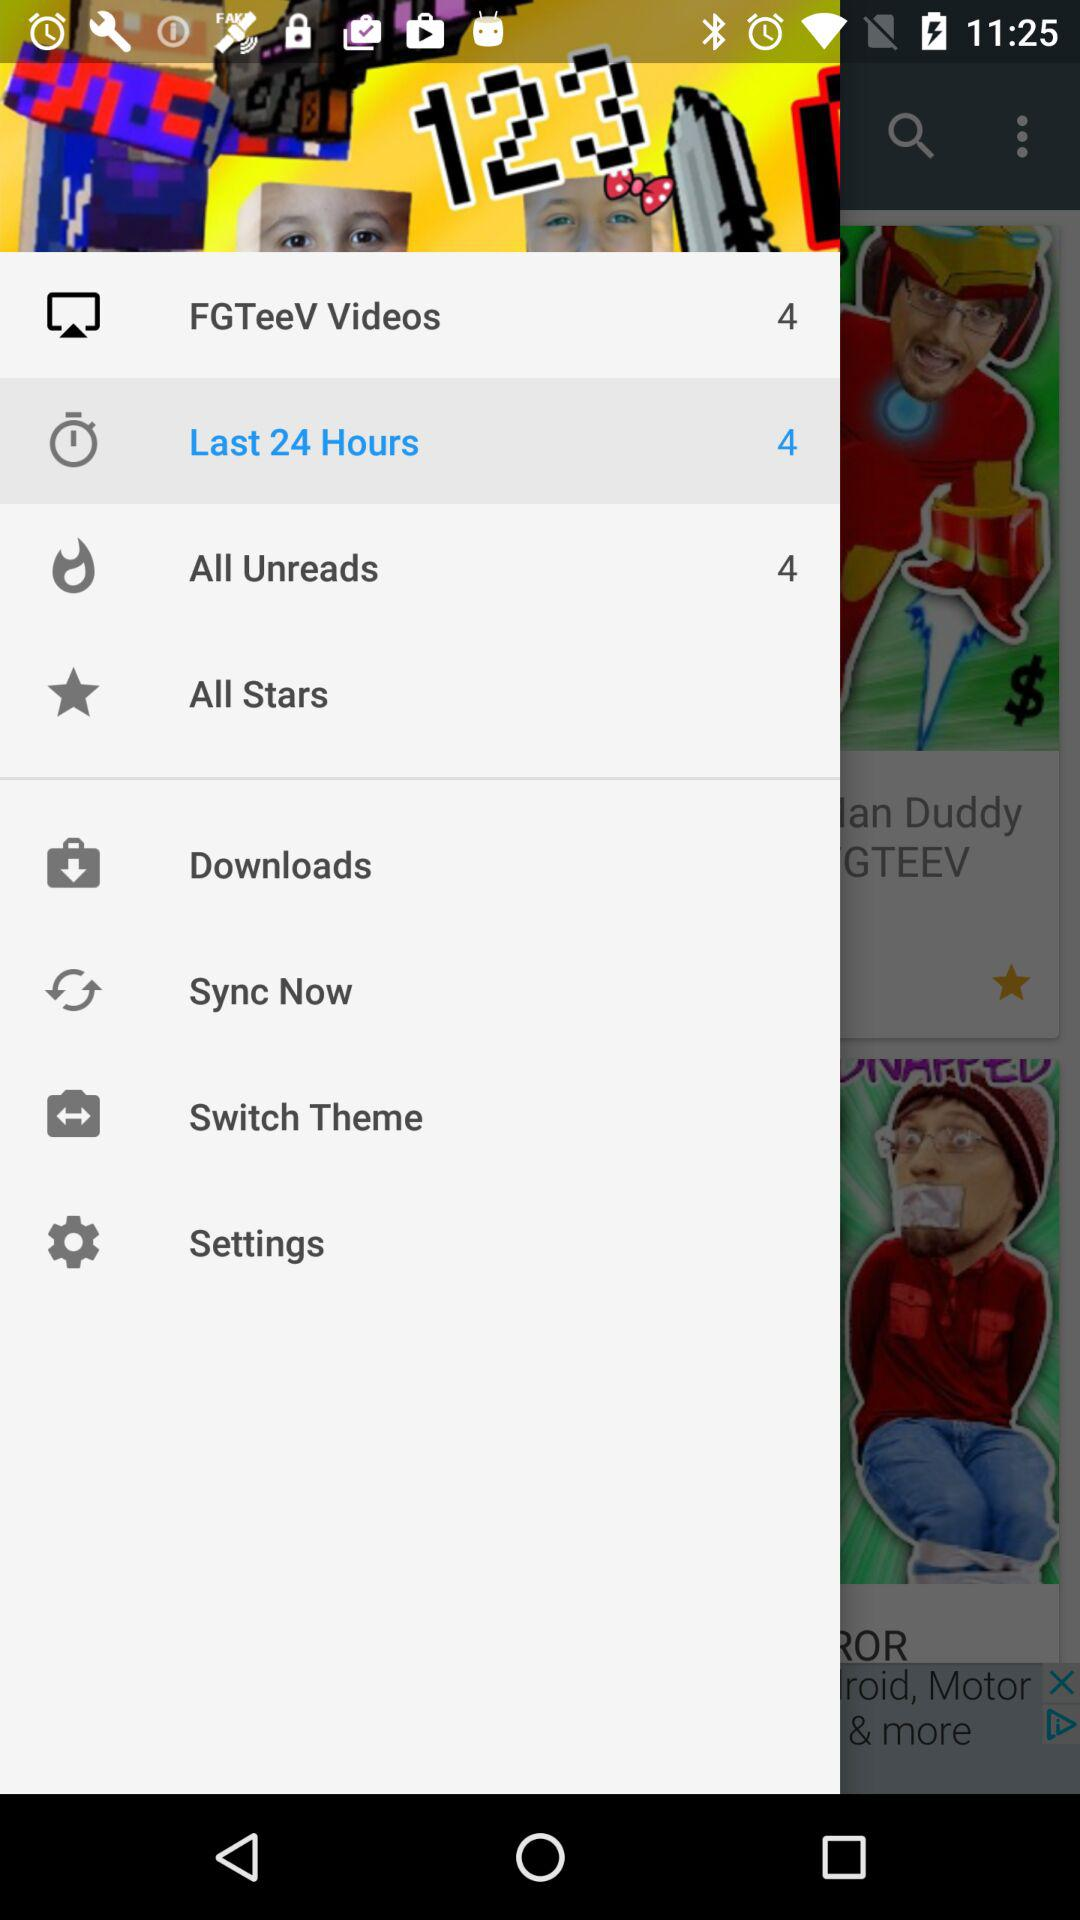How many unread messages are there? There are 4 unread messages. 